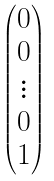Convert formula to latex. <formula><loc_0><loc_0><loc_500><loc_500>\begin{pmatrix} 0 \\ 0 \\ \vdots \\ 0 \\ 1 \end{pmatrix}</formula> 